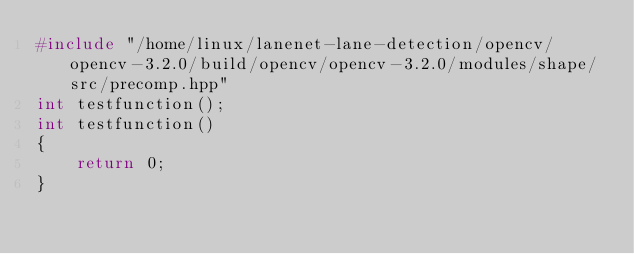Convert code to text. <code><loc_0><loc_0><loc_500><loc_500><_C++_>#include "/home/linux/lanenet-lane-detection/opencv/opencv-3.2.0/build/opencv/opencv-3.2.0/modules/shape/src/precomp.hpp"
int testfunction();
int testfunction()
{
    return 0;
}
</code> 